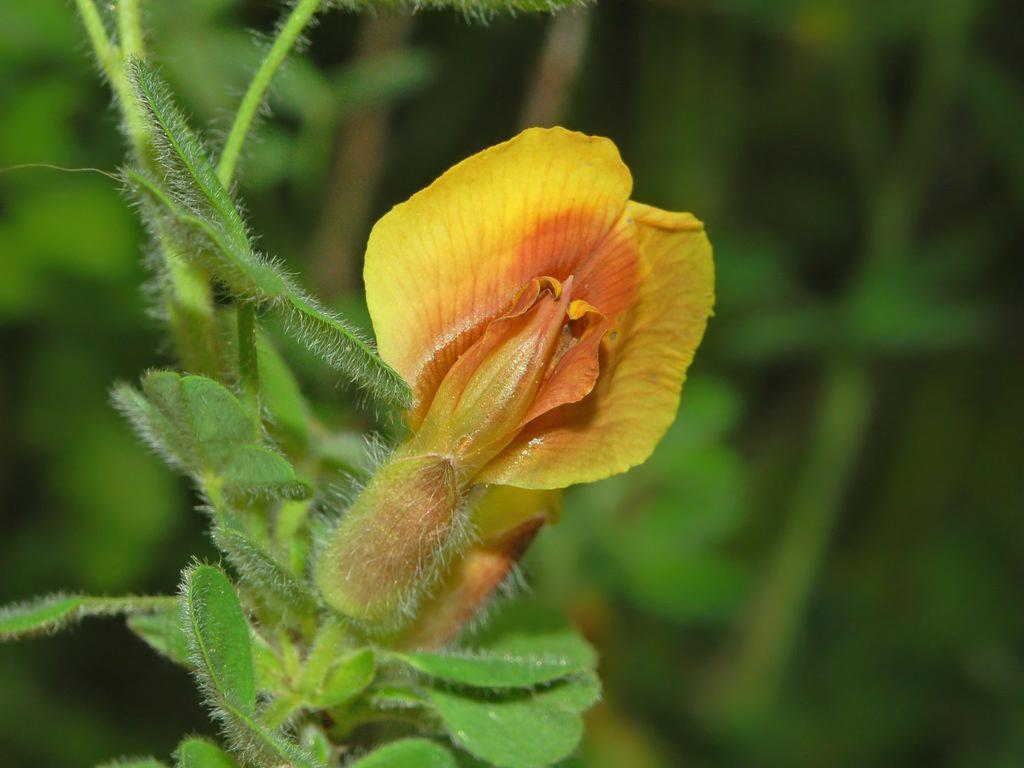What is the main subject of the image? There is a flower in the image. Can you describe the colors of the flower? The flower has yellow and orange colors. Is the flower part of a larger plant? Yes, the flower is attached to a plant. What color is the plant? The plant has a green color. How would you describe the background of the image? The background of the image is blurry and has green and black colors. Can you tell me how many geese are in the background of the image? There are no geese present in the image; the background has green and black colors. What type of notebook is the doctor using to take notes in the image? There is no doctor or notebook present in the image; it features a flower and a plant. 